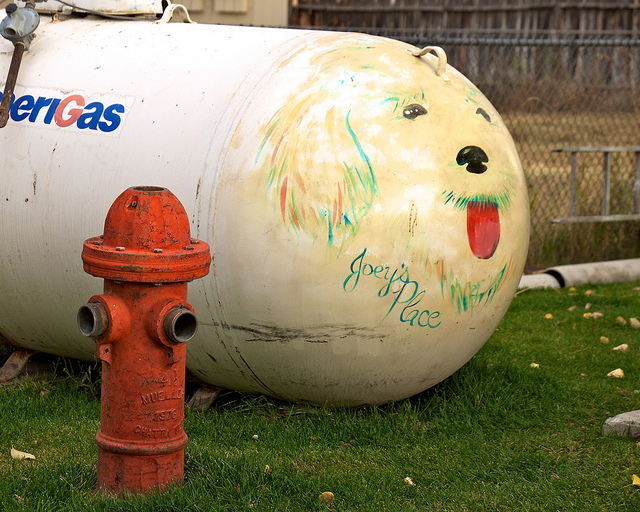Please extract the text content from this image. Place eriGas MUSIC Place Joey's 